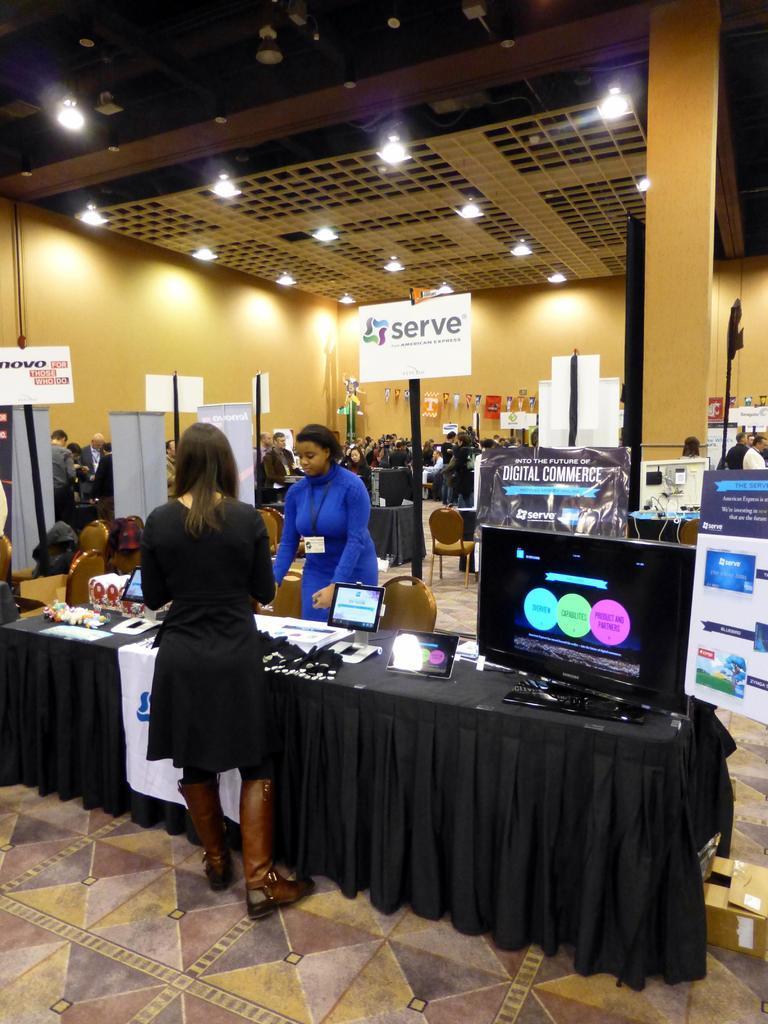In one or two sentences, can you explain what this image depicts? This image there are a group of people, and there are some tables. On the table there is television, and some small screens and some objects. And in the background there are some boards, poles, chairs, and some posters and some people are standing, and also there are some objects and wires and some machines. At the bottom there is floor and there are some boxes, at the top there is ceiling and some lights. And on the right side of the image there are pillars. 